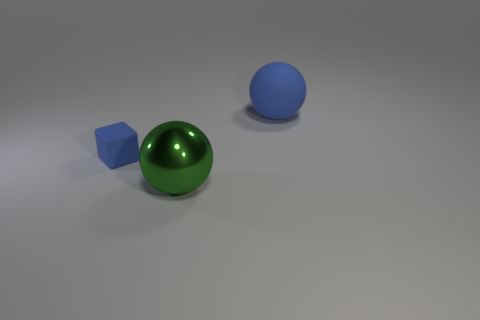Add 1 tiny balls. How many objects exist? 4 Subtract all blocks. How many objects are left? 2 Add 1 matte spheres. How many matte spheres exist? 2 Subtract 0 brown cubes. How many objects are left? 3 Subtract all small blue rubber cubes. Subtract all small blue blocks. How many objects are left? 1 Add 2 large green objects. How many large green objects are left? 3 